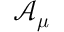<formula> <loc_0><loc_0><loc_500><loc_500>\mathcal { A } _ { \mu }</formula> 